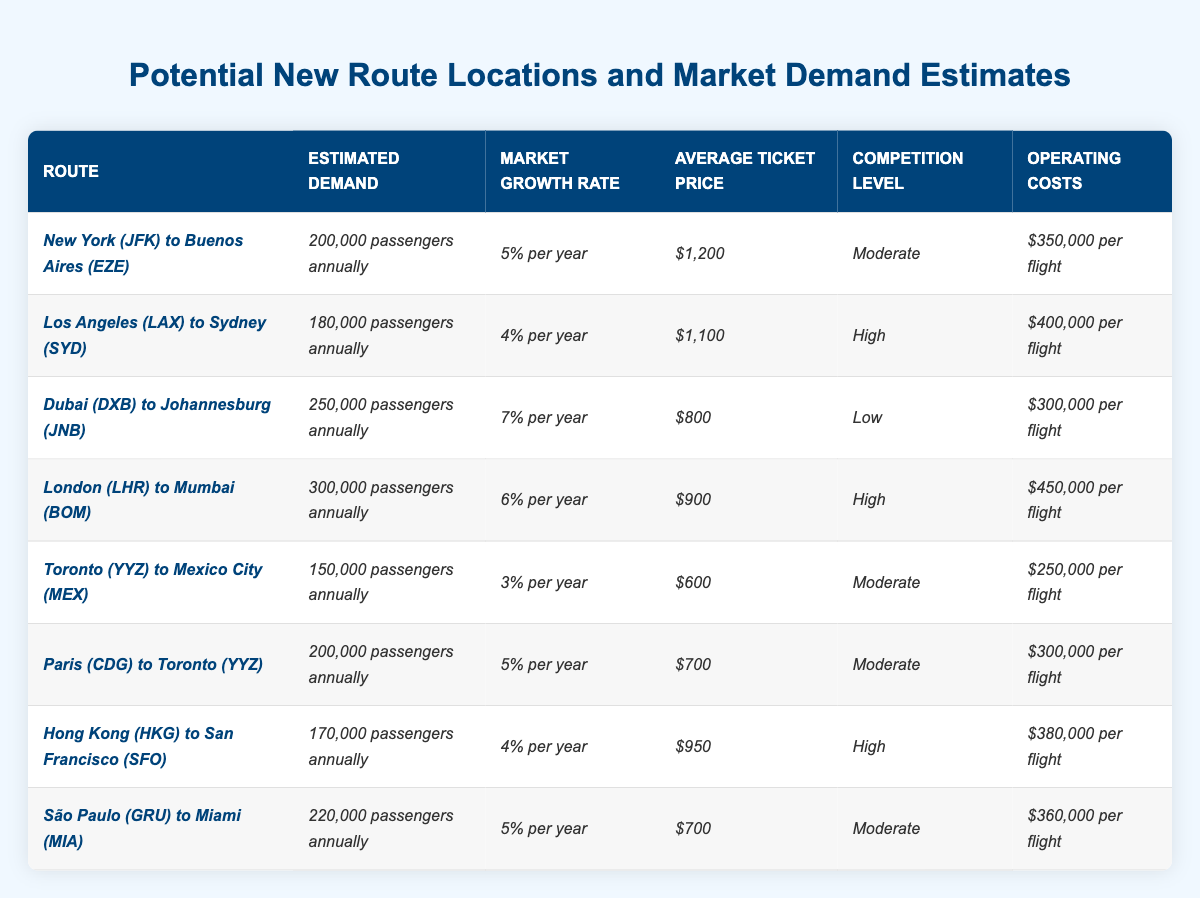What is the estimated demand for the route from New York (JFK) to Buenos Aires (EZE)? According to the table, the estimated demand for this route is directly listed as 200,000 passengers annually.
Answer: 200,000 passengers annually Which route has the highest average ticket price? By reviewing the table, the average ticket prices for all routes are compared, and the route from New York (JFK) to Buenos Aires (EZE) has the highest average ticket price at $1,200.
Answer: New York (JFK) to Buenos Aires (EZE) What are the operating costs for the route from Toronto (YYZ) to Mexico City (MEX)? The operating costs for this route are clearly stated in the table as $250,000 per flight.
Answer: $250,000 per flight What is the competition level for the route from Dubai (DXB) to Johannesburg (JNB)? The competition level for this route is listed as "Low" in the table.
Answer: Low How many more passengers are estimated for the route from São Paulo (GRU) to Miami (MIA) compared to the route from Toronto (YYZ) to Mexico City (MEX)? The estimated demand for São Paulo (GRU) to Miami (MIA) is 220,000 passengers annually, while for Toronto (YYZ) to Mexico City (MEX) it is 150,000 passengers annually. The difference is 220,000 - 150,000 = 70,000 passengers.
Answer: 70,000 passengers What is the average estimated demand for all routes listed in the table? The estimated demands are: 200,000, 180,000, 250,000, 300,000, 150,000, 200,000, 170,000, and 220,000. Summing them gives 200,000 + 180,000 + 250,000 + 300,000 + 150,000 + 200,000 + 170,000 + 220,000 = 1,670,000. There are 8 routes, so the average is 1,670,000 / 8 = 208,750.
Answer: 208,750 Is the market growth rate for the route from Hong Kong (HKG) to San Francisco (SFO) higher than for the route from Toronto (YYZ) to Mexico City (MEX)? The market growth rate for Hong Kong (HKG) to San Francisco (SFO) is 4% per year and for Toronto (YYZ) to Mexico City (MEX) is 3% per year. Since 4% is greater than 3%, the answer is yes.
Answer: Yes Which route has the lowest operating costs and what is the value? By examining the operating costs in the table, the route from Toronto (YYZ) to Mexico City (MEX) has the lowest operating cost at $250,000 per flight.
Answer: Toronto (YYZ) to Mexico City (MEX), $250,000 per flight If competition is high on a route, does it also tend to have a higher average ticket price? Compiling the data from the table, the routes with high competition levels (Los Angeles to Sydney, London to Mumbai, Hong Kong to San Francisco) have average ticket prices of $1,100, $900, and $950, respectively, which are generally lower than the average ticket price of $1,200 for New York to Buenos Aires (EZE), which has moderate competition. Therefore, it’s not consistently true that high competition means higher ticket prices.
Answer: No What is the total estimated demand for routes that have a market growth rate above 5%? The routes with a market growth rate above 5% are Dubai to Johannesburg (7%) and London to Mumbai (6%). Their estimated demands are 250,000 and 300,000 respectively. The total is 250,000 + 300,000 = 550,000.
Answer: 550,000 